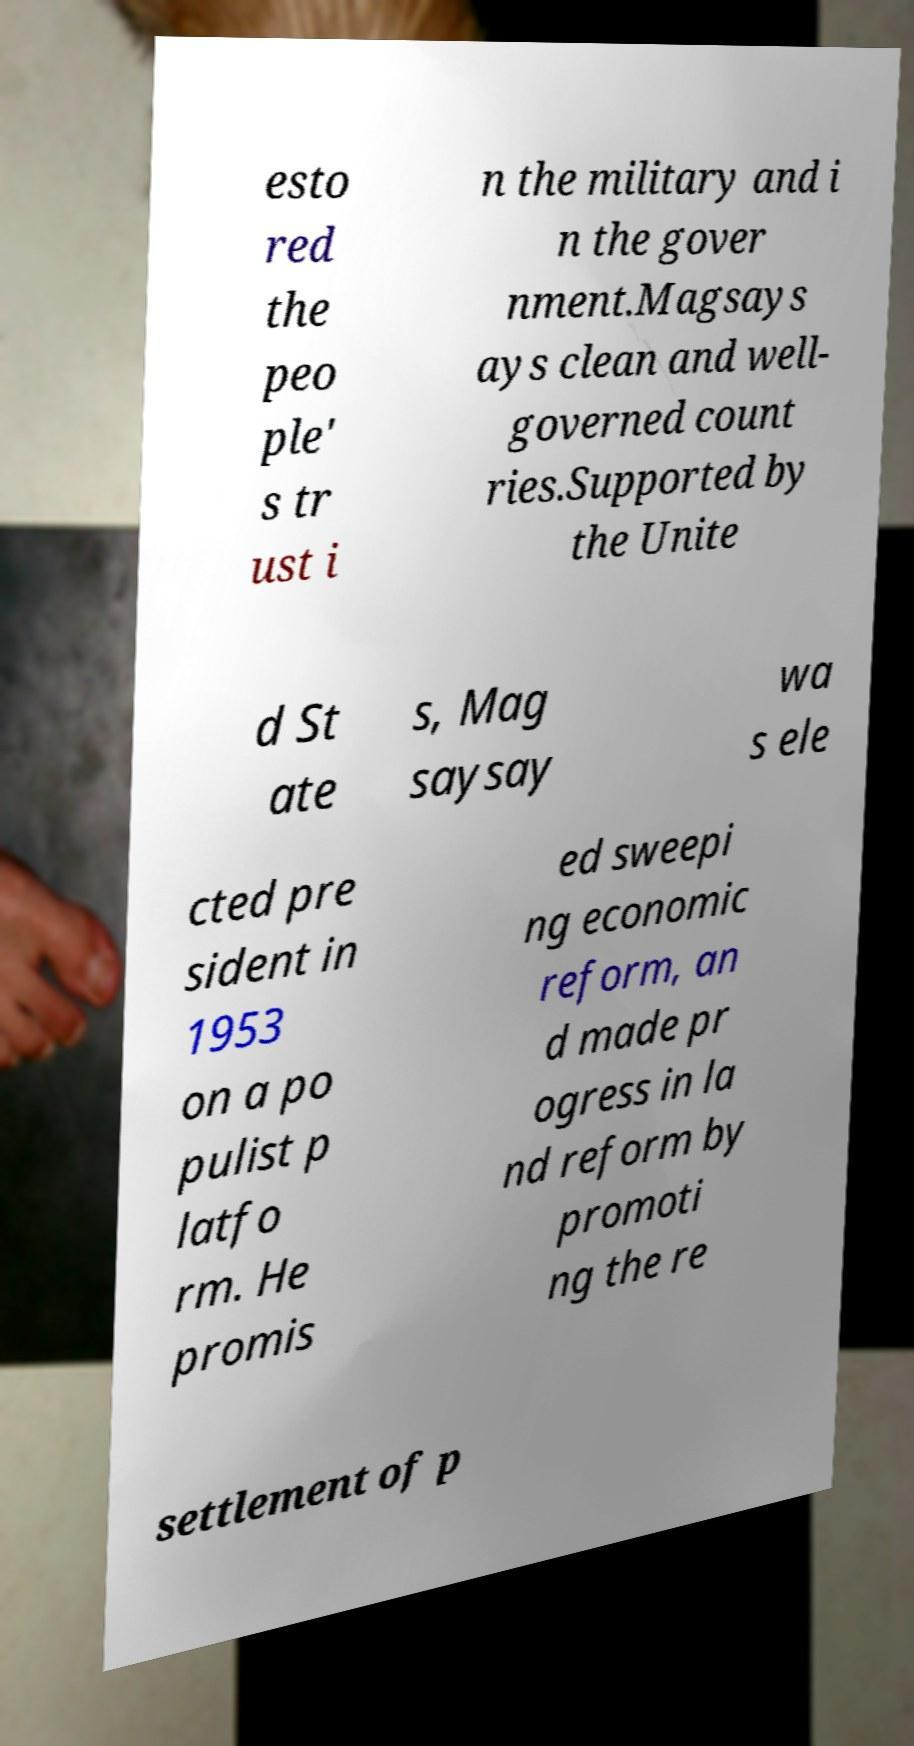Can you read and provide the text displayed in the image?This photo seems to have some interesting text. Can you extract and type it out for me? esto red the peo ple' s tr ust i n the military and i n the gover nment.Magsays ays clean and well- governed count ries.Supported by the Unite d St ate s, Mag saysay wa s ele cted pre sident in 1953 on a po pulist p latfo rm. He promis ed sweepi ng economic reform, an d made pr ogress in la nd reform by promoti ng the re settlement of p 